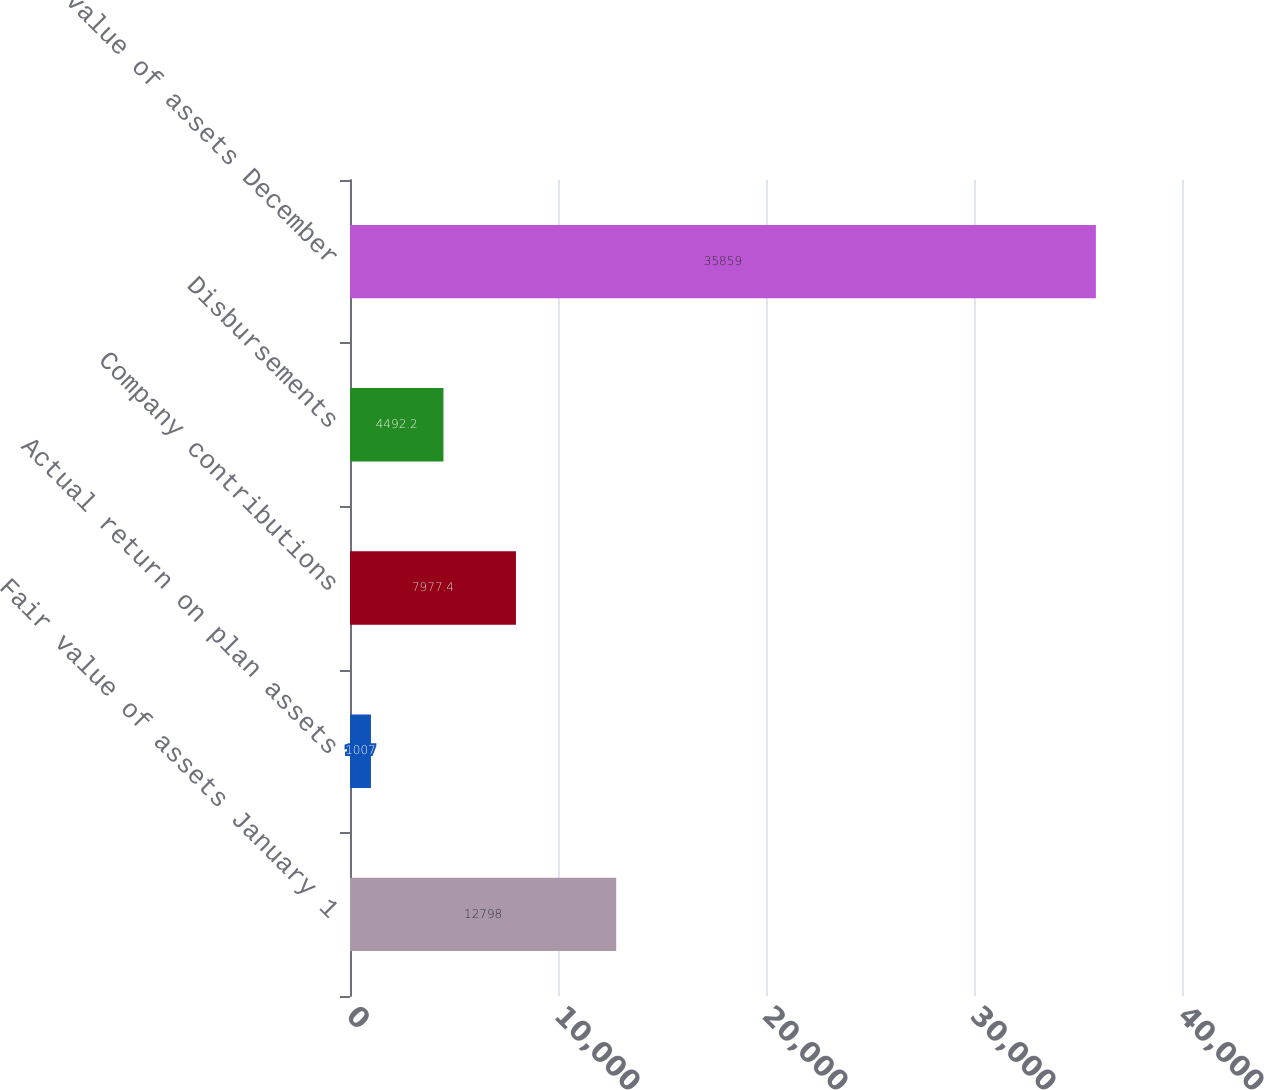Convert chart to OTSL. <chart><loc_0><loc_0><loc_500><loc_500><bar_chart><fcel>Fair value of assets January 1<fcel>Actual return on plan assets<fcel>Company contributions<fcel>Disbursements<fcel>Fair value of assets December<nl><fcel>12798<fcel>1007<fcel>7977.4<fcel>4492.2<fcel>35859<nl></chart> 